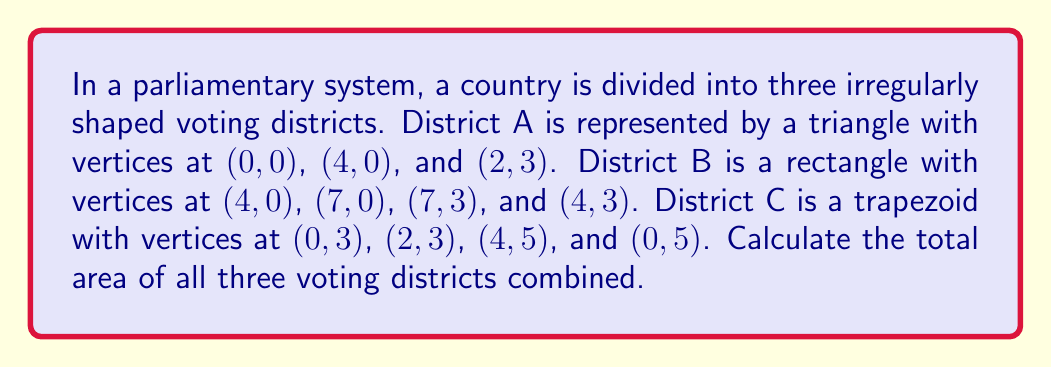What is the answer to this math problem? Let's calculate the area of each district separately and then sum them up:

1. District A (Triangle):
   Area of a triangle = $\frac{1}{2} \times base \times height$
   Base = 4, Height = 3
   $A_A = \frac{1}{2} \times 4 \times 3 = 6$ square units

2. District B (Rectangle):
   Area of a rectangle = length $\times$ width
   Length = 7 - 4 = 3, Width = 3
   $A_B = 3 \times 3 = 9$ square units

3. District C (Trapezoid):
   Area of a trapezoid = $\frac{1}{2}(a+b)h$, where $a$ and $b$ are the parallel sides and $h$ is the height
   $a = 2$, $b = 4$, $h = 2$
   $A_C = \frac{1}{2}(2+4) \times 2 = 6$ square units

Total area = $A_A + A_B + A_C = 6 + 9 + 6 = 21$ square units

[asy]
unitsize(1cm);
draw((0,0)--(4,0)--(2,3)--cycle);
draw((4,0)--(7,0)--(7,3)--(4,3)--cycle);
draw((0,3)--(2,3)--(4,5)--(0,5)--cycle);
label("A", (2,1));
label("B", (5.5,1.5));
label("C", (2,4));
[/asy]
Answer: 21 square units 